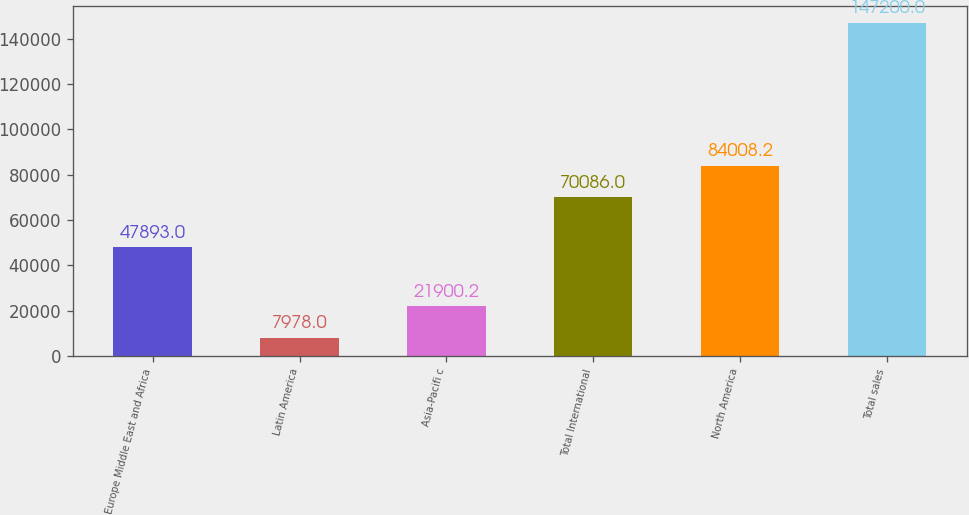<chart> <loc_0><loc_0><loc_500><loc_500><bar_chart><fcel>Europe Middle East and Africa<fcel>Latin America<fcel>Asia-Pacifi c<fcel>Total International<fcel>North America<fcel>Total sales<nl><fcel>47893<fcel>7978<fcel>21900.2<fcel>70086<fcel>84008.2<fcel>147200<nl></chart> 